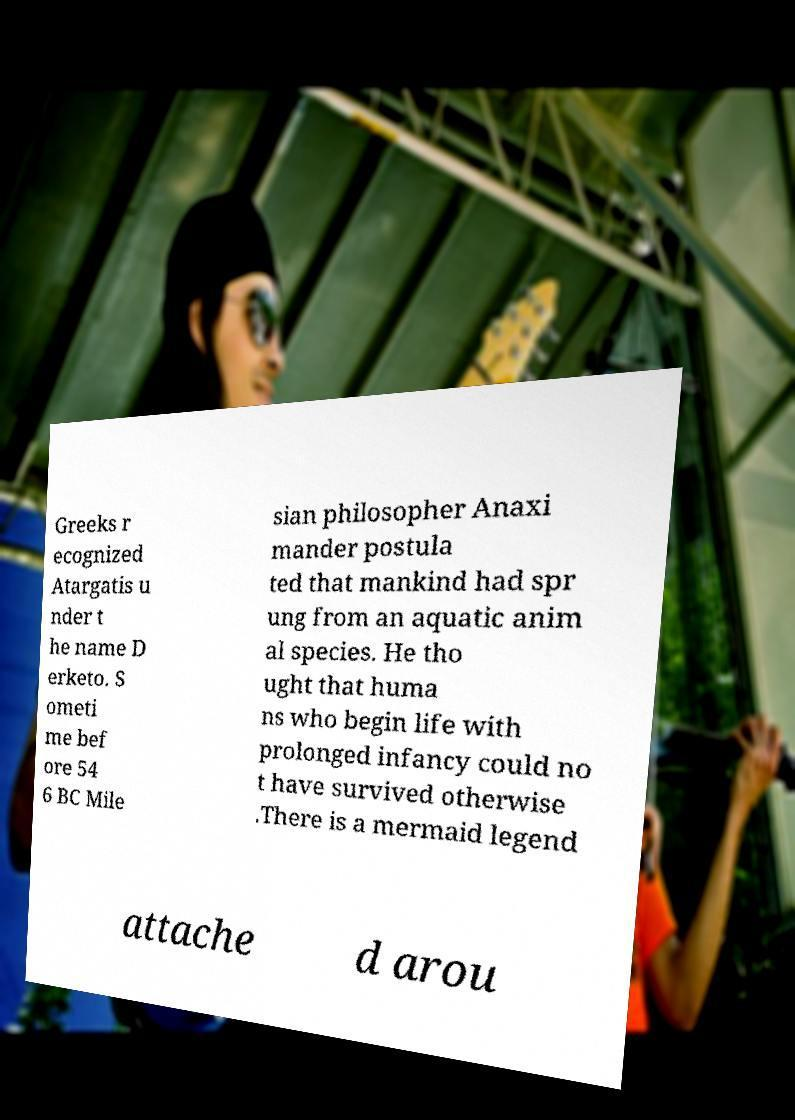Please read and relay the text visible in this image. What does it say? Greeks r ecognized Atargatis u nder t he name D erketo. S ometi me bef ore 54 6 BC Mile sian philosopher Anaxi mander postula ted that mankind had spr ung from an aquatic anim al species. He tho ught that huma ns who begin life with prolonged infancy could no t have survived otherwise .There is a mermaid legend attache d arou 